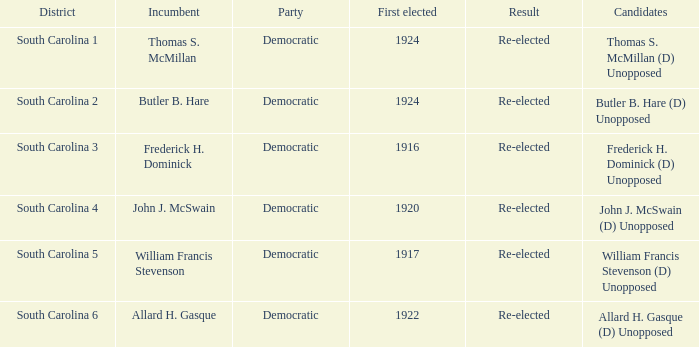What is the consequence for thomas s. mcmillan? Re-elected. 